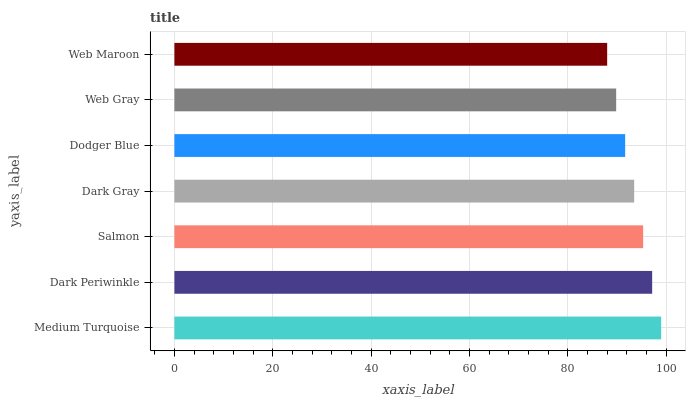Is Web Maroon the minimum?
Answer yes or no. Yes. Is Medium Turquoise the maximum?
Answer yes or no. Yes. Is Dark Periwinkle the minimum?
Answer yes or no. No. Is Dark Periwinkle the maximum?
Answer yes or no. No. Is Medium Turquoise greater than Dark Periwinkle?
Answer yes or no. Yes. Is Dark Periwinkle less than Medium Turquoise?
Answer yes or no. Yes. Is Dark Periwinkle greater than Medium Turquoise?
Answer yes or no. No. Is Medium Turquoise less than Dark Periwinkle?
Answer yes or no. No. Is Dark Gray the high median?
Answer yes or no. Yes. Is Dark Gray the low median?
Answer yes or no. Yes. Is Web Maroon the high median?
Answer yes or no. No. Is Web Gray the low median?
Answer yes or no. No. 